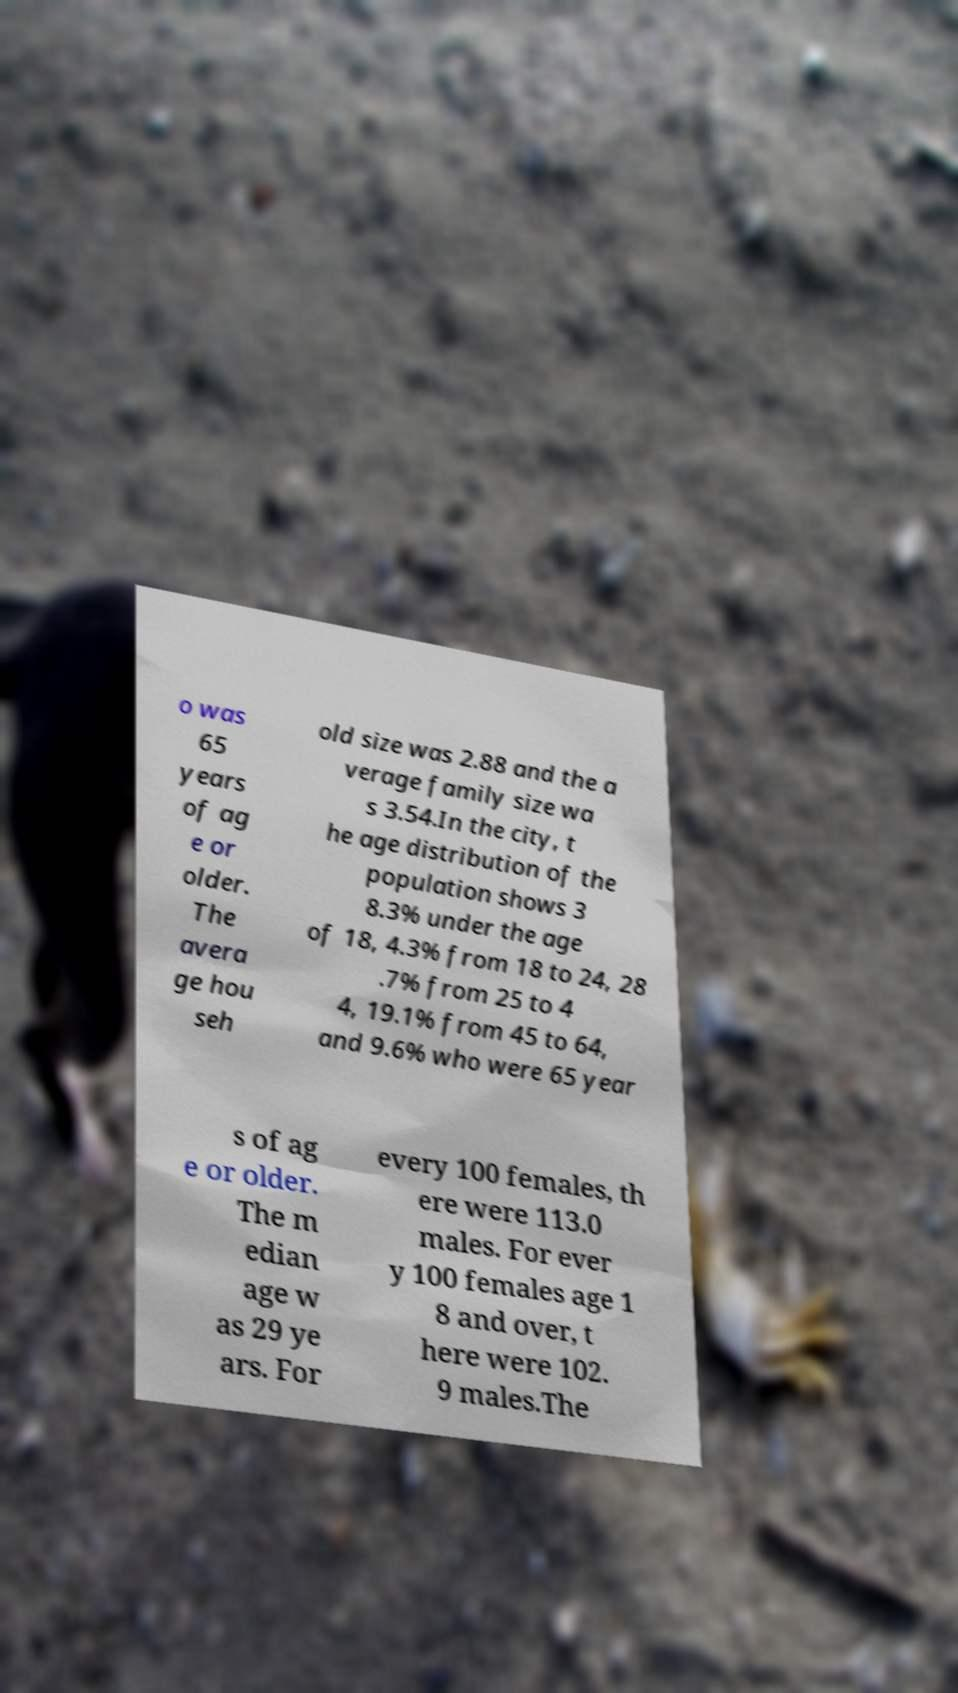Can you accurately transcribe the text from the provided image for me? o was 65 years of ag e or older. The avera ge hou seh old size was 2.88 and the a verage family size wa s 3.54.In the city, t he age distribution of the population shows 3 8.3% under the age of 18, 4.3% from 18 to 24, 28 .7% from 25 to 4 4, 19.1% from 45 to 64, and 9.6% who were 65 year s of ag e or older. The m edian age w as 29 ye ars. For every 100 females, th ere were 113.0 males. For ever y 100 females age 1 8 and over, t here were 102. 9 males.The 